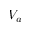<formula> <loc_0><loc_0><loc_500><loc_500>V _ { a }</formula> 